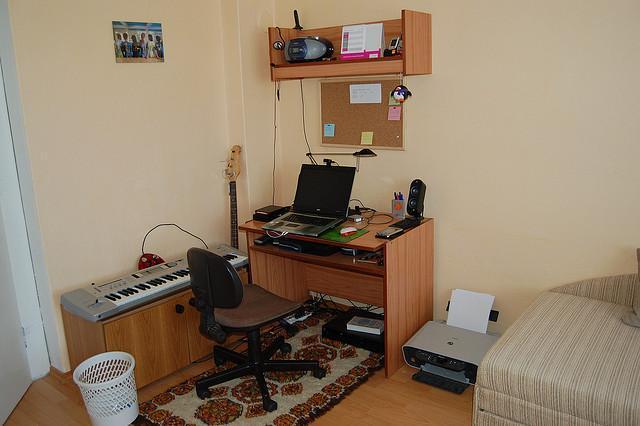How many of the fruit that can be seen in the bowl are bananas?
Give a very brief answer. 0. 